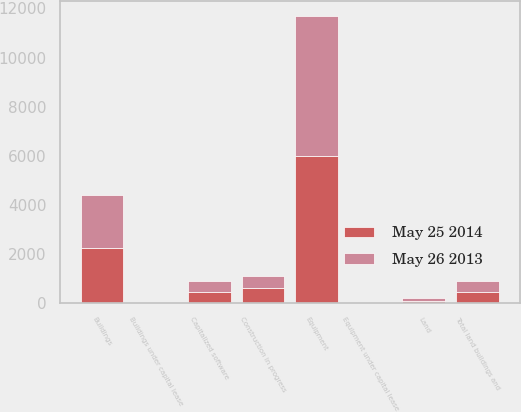<chart> <loc_0><loc_0><loc_500><loc_500><stacked_bar_chart><ecel><fcel>Land<fcel>Buildings<fcel>Buildings under capital lease<fcel>Equipment<fcel>Equipment under capital lease<fcel>Capitalized software<fcel>Construction in progress<fcel>Total land buildings and<nl><fcel>May 25 2014<fcel>106.9<fcel>2228.4<fcel>0.3<fcel>5979.7<fcel>9<fcel>468<fcel>600.8<fcel>447.95<nl><fcel>May 26 2013<fcel>101.2<fcel>2168.3<fcel>0.3<fcel>5731.1<fcel>9<fcel>427.9<fcel>495.1<fcel>447.95<nl></chart> 